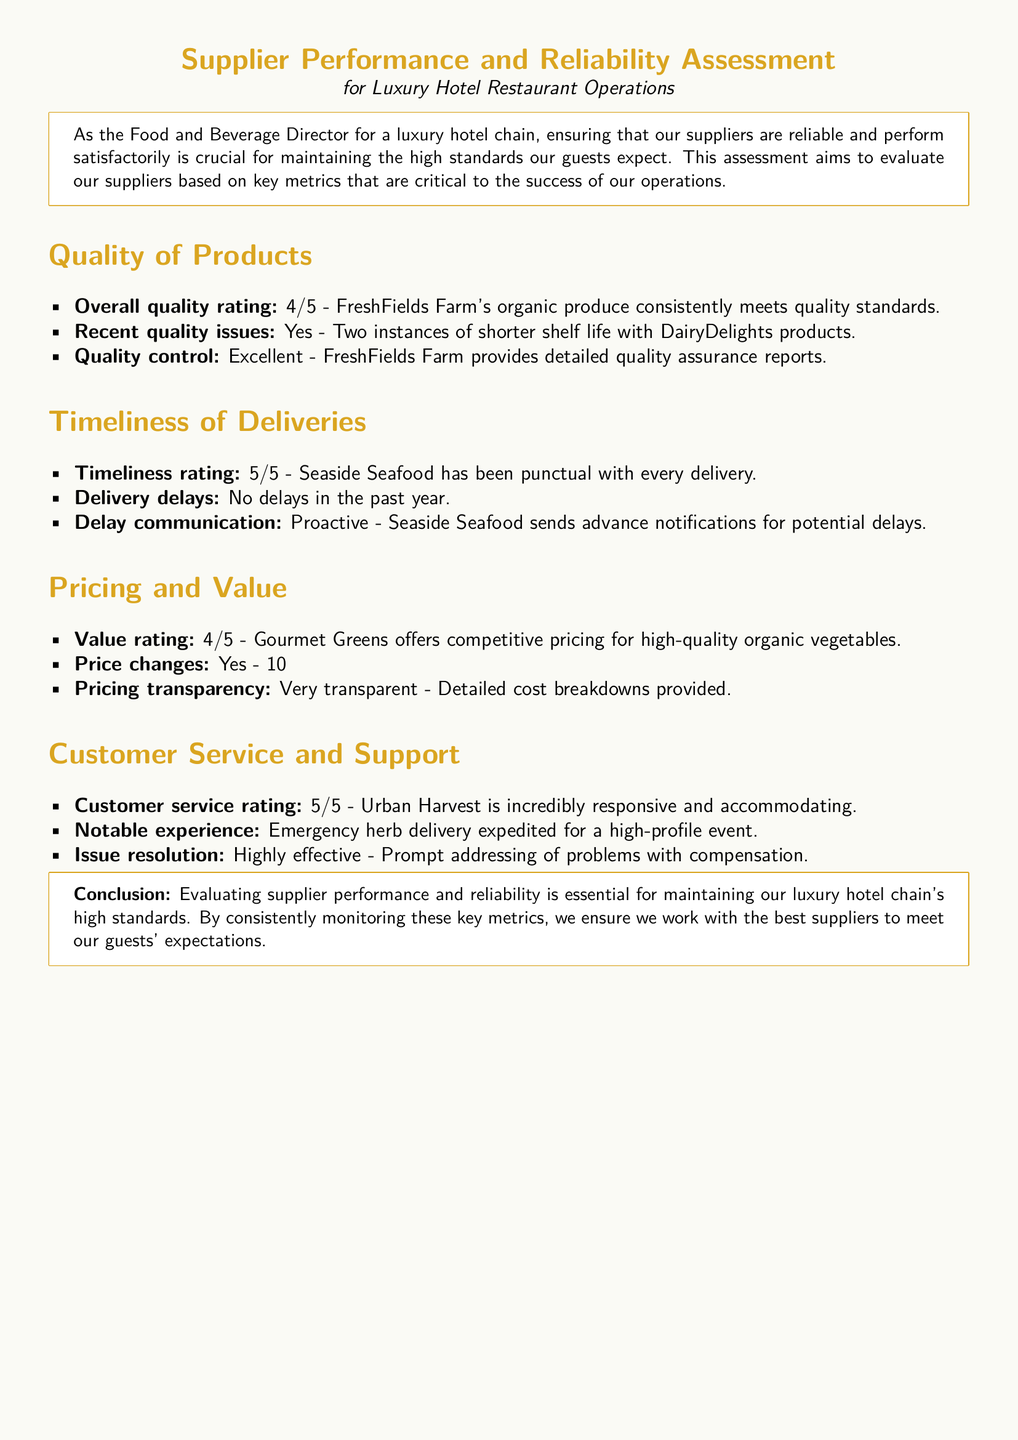what is the overall quality rating for FreshFields Farm's organic produce? The overall quality rating is specified in the document as 4 out of 5.
Answer: 4/5 how many instances of recent quality issues are reported for DairyDelights products? The document mentions two instances of shorter shelf life, indicating issues with DairyDelights products.
Answer: Two what is the timeliness rating for Seaside Seafood? The timeliness rating is provided as 5 out of 5 for Seaside Seafood.
Answer: 5/5 has there been any delivery delays in the past year? The document explicitly states that there have been no delivery delays in the past year for Seaside Seafood.
Answer: No what is the pricing transparency level for Gourmet Greens? The document characterizes the pricing transparency of Gourmet Greens as very transparent.
Answer: Very transparent what notable experience is mentioned for Urban Harvest customer service? The document highlights an emergency herb delivery that was expedited for a high-profile event as a notable customer service experience.
Answer: Emergency herb delivery what is the value rating for Gourmet Greens? The value rating for Gourmet Greens, according to the document, is 4 out of 5.
Answer: 4/5 how did Urban Harvest address issues? The document states that Urban Harvest has a highly effective approach to issue resolution.
Answer: Highly effective what is the conclusion regarding supplier performance assessment? The conclusion emphasizes that evaluating supplier performance is essential for maintaining high standards at the luxury hotel chain.
Answer: Essential for maintaining high standards 